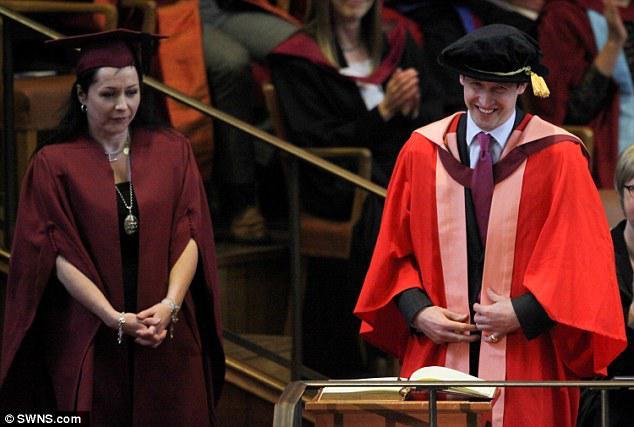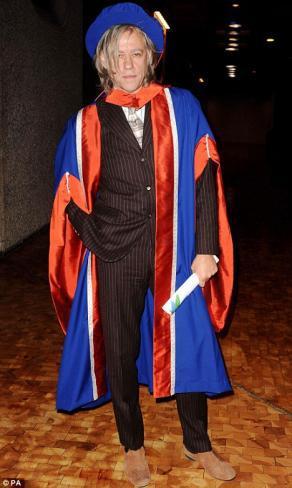The first image is the image on the left, the second image is the image on the right. Considering the images on both sides, is "An image shows a woman in a burgundy graduation robe next to a man in a bright red robe with pink and burgundy sashes." valid? Answer yes or no. Yes. 